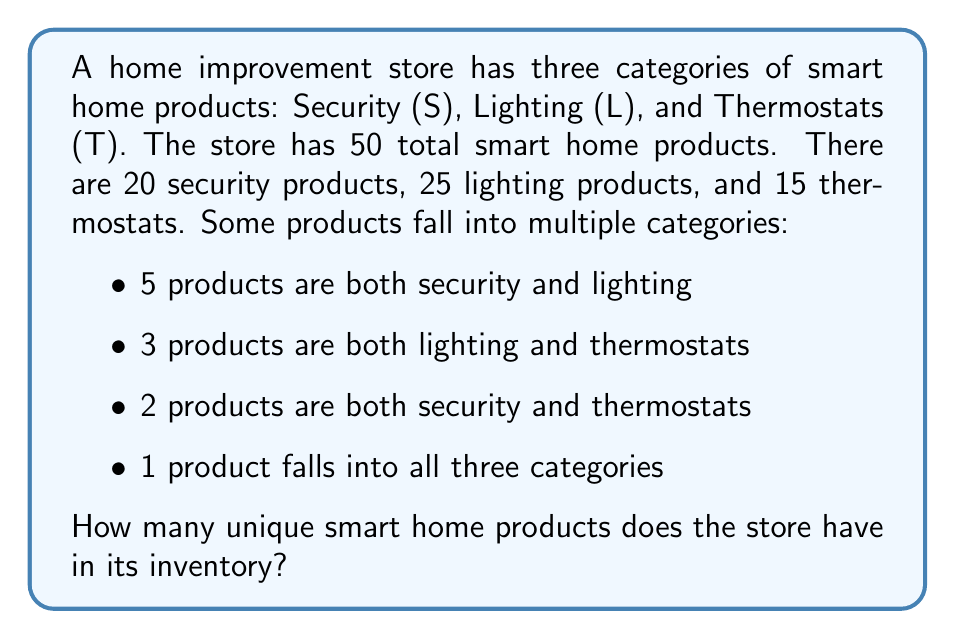Give your solution to this math problem. To solve this problem, we can use the principle of inclusion-exclusion from set theory. Let's break it down step-by-step:

1. Define our sets:
   S = Security products
   L = Lighting products
   T = Thermostat products

2. We're given:
   $|S| = 20$, $|L| = 25$, $|T| = 15$
   $|S \cap L| = 5$, $|L \cap T| = 3$, $|S \cap T| = 2$
   $|S \cap L \cap T| = 1$

3. The formula for three sets is:
   $$|S \cup L \cup T| = |S| + |L| + |T| - |S \cap L| - |L \cap T| - |S \cap T| + |S \cap L \cap T|$$

4. Substituting our values:
   $$|S \cup L \cup T| = 20 + 25 + 15 - 5 - 3 - 2 + 1$$

5. Calculate:
   $$|S \cup L \cup T| = 60 - 10 + 1 = 51$$

6. However, we're told there are only 50 total products. This discrepancy is because we've counted the product that falls into all three categories twice in our subtraction, so we need to subtract it once more:

   $$\text{Unique products} = 51 - 1 = 50$$

This matches our given total and represents the number of unique products in the inventory.
Answer: The store has 50 unique smart home products in its inventory. 